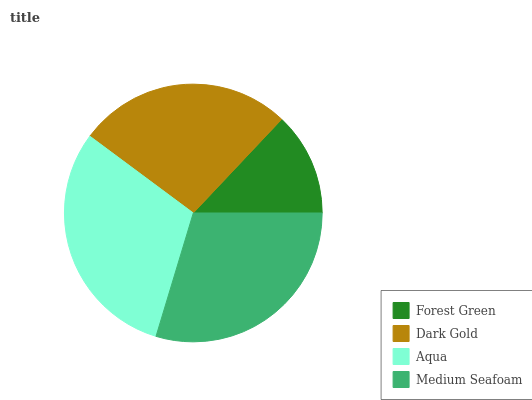Is Forest Green the minimum?
Answer yes or no. Yes. Is Aqua the maximum?
Answer yes or no. Yes. Is Dark Gold the minimum?
Answer yes or no. No. Is Dark Gold the maximum?
Answer yes or no. No. Is Dark Gold greater than Forest Green?
Answer yes or no. Yes. Is Forest Green less than Dark Gold?
Answer yes or no. Yes. Is Forest Green greater than Dark Gold?
Answer yes or no. No. Is Dark Gold less than Forest Green?
Answer yes or no. No. Is Medium Seafoam the high median?
Answer yes or no. Yes. Is Dark Gold the low median?
Answer yes or no. Yes. Is Dark Gold the high median?
Answer yes or no. No. Is Forest Green the low median?
Answer yes or no. No. 